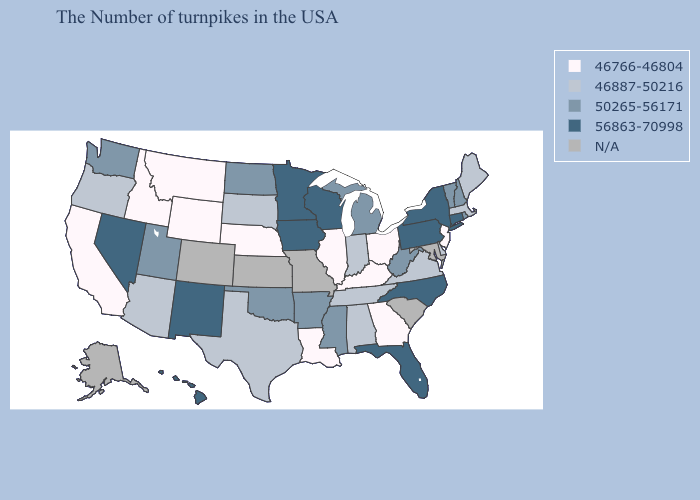Name the states that have a value in the range 56863-70998?
Give a very brief answer. Connecticut, New York, Pennsylvania, North Carolina, Florida, Wisconsin, Minnesota, Iowa, New Mexico, Nevada, Hawaii. Name the states that have a value in the range N/A?
Keep it brief. Maryland, South Carolina, Missouri, Kansas, Colorado, Alaska. What is the value of Iowa?
Answer briefly. 56863-70998. Name the states that have a value in the range 50265-56171?
Be succinct. Rhode Island, New Hampshire, Vermont, West Virginia, Michigan, Mississippi, Arkansas, Oklahoma, North Dakota, Utah, Washington. Name the states that have a value in the range 56863-70998?
Be succinct. Connecticut, New York, Pennsylvania, North Carolina, Florida, Wisconsin, Minnesota, Iowa, New Mexico, Nevada, Hawaii. Name the states that have a value in the range N/A?
Quick response, please. Maryland, South Carolina, Missouri, Kansas, Colorado, Alaska. What is the value of Illinois?
Keep it brief. 46766-46804. Does North Dakota have the lowest value in the MidWest?
Concise answer only. No. Among the states that border Vermont , does Massachusetts have the lowest value?
Keep it brief. Yes. What is the value of Virginia?
Answer briefly. 46887-50216. Which states have the lowest value in the USA?
Concise answer only. New Jersey, Ohio, Georgia, Kentucky, Illinois, Louisiana, Nebraska, Wyoming, Montana, Idaho, California. Does the map have missing data?
Concise answer only. Yes. Among the states that border Oklahoma , does Arkansas have the lowest value?
Answer briefly. No. 